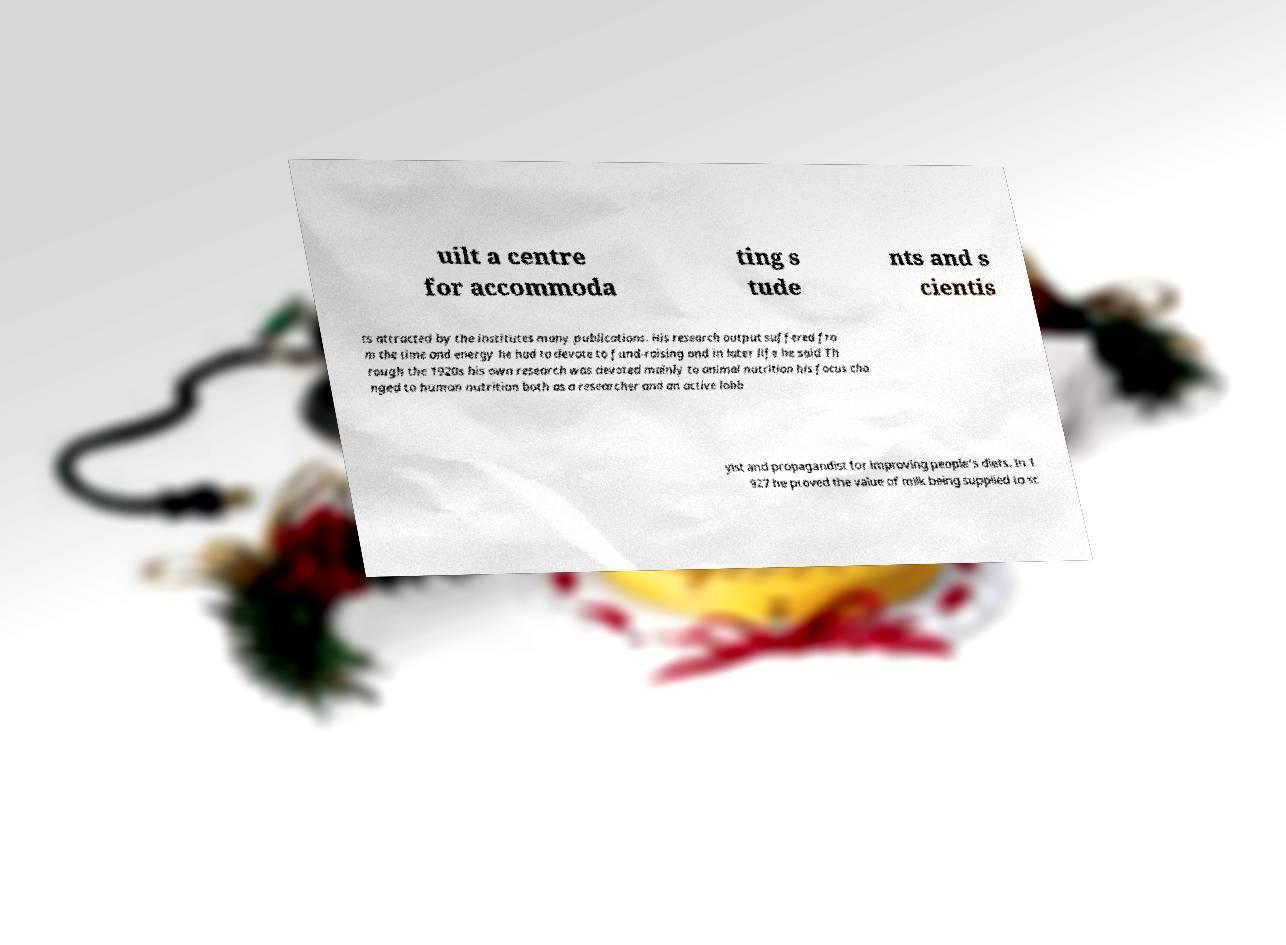Can you accurately transcribe the text from the provided image for me? uilt a centre for accommoda ting s tude nts and s cientis ts attracted by the institutes many publications. His research output suffered fro m the time and energy he had to devote to fund-raising and in later life he said Th rough the 1920s his own research was devoted mainly to animal nutrition his focus cha nged to human nutrition both as a researcher and an active lobb yist and propagandist for improving people's diets. In 1 927 he proved the value of milk being supplied to sc 